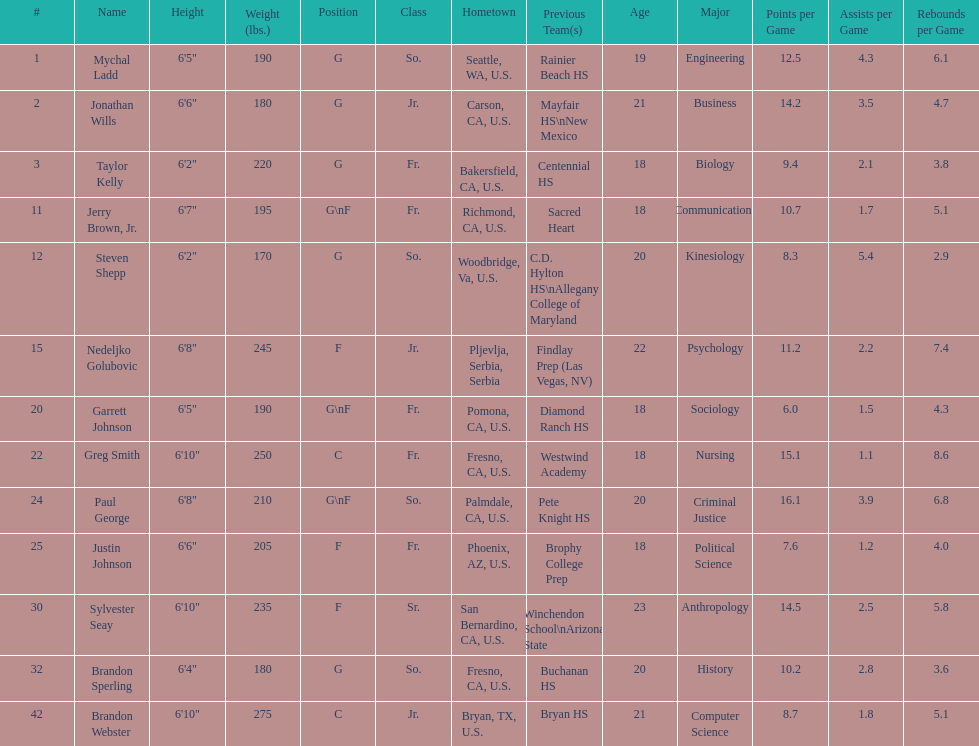Which player is taller, paul george or greg smith? Greg Smith. 